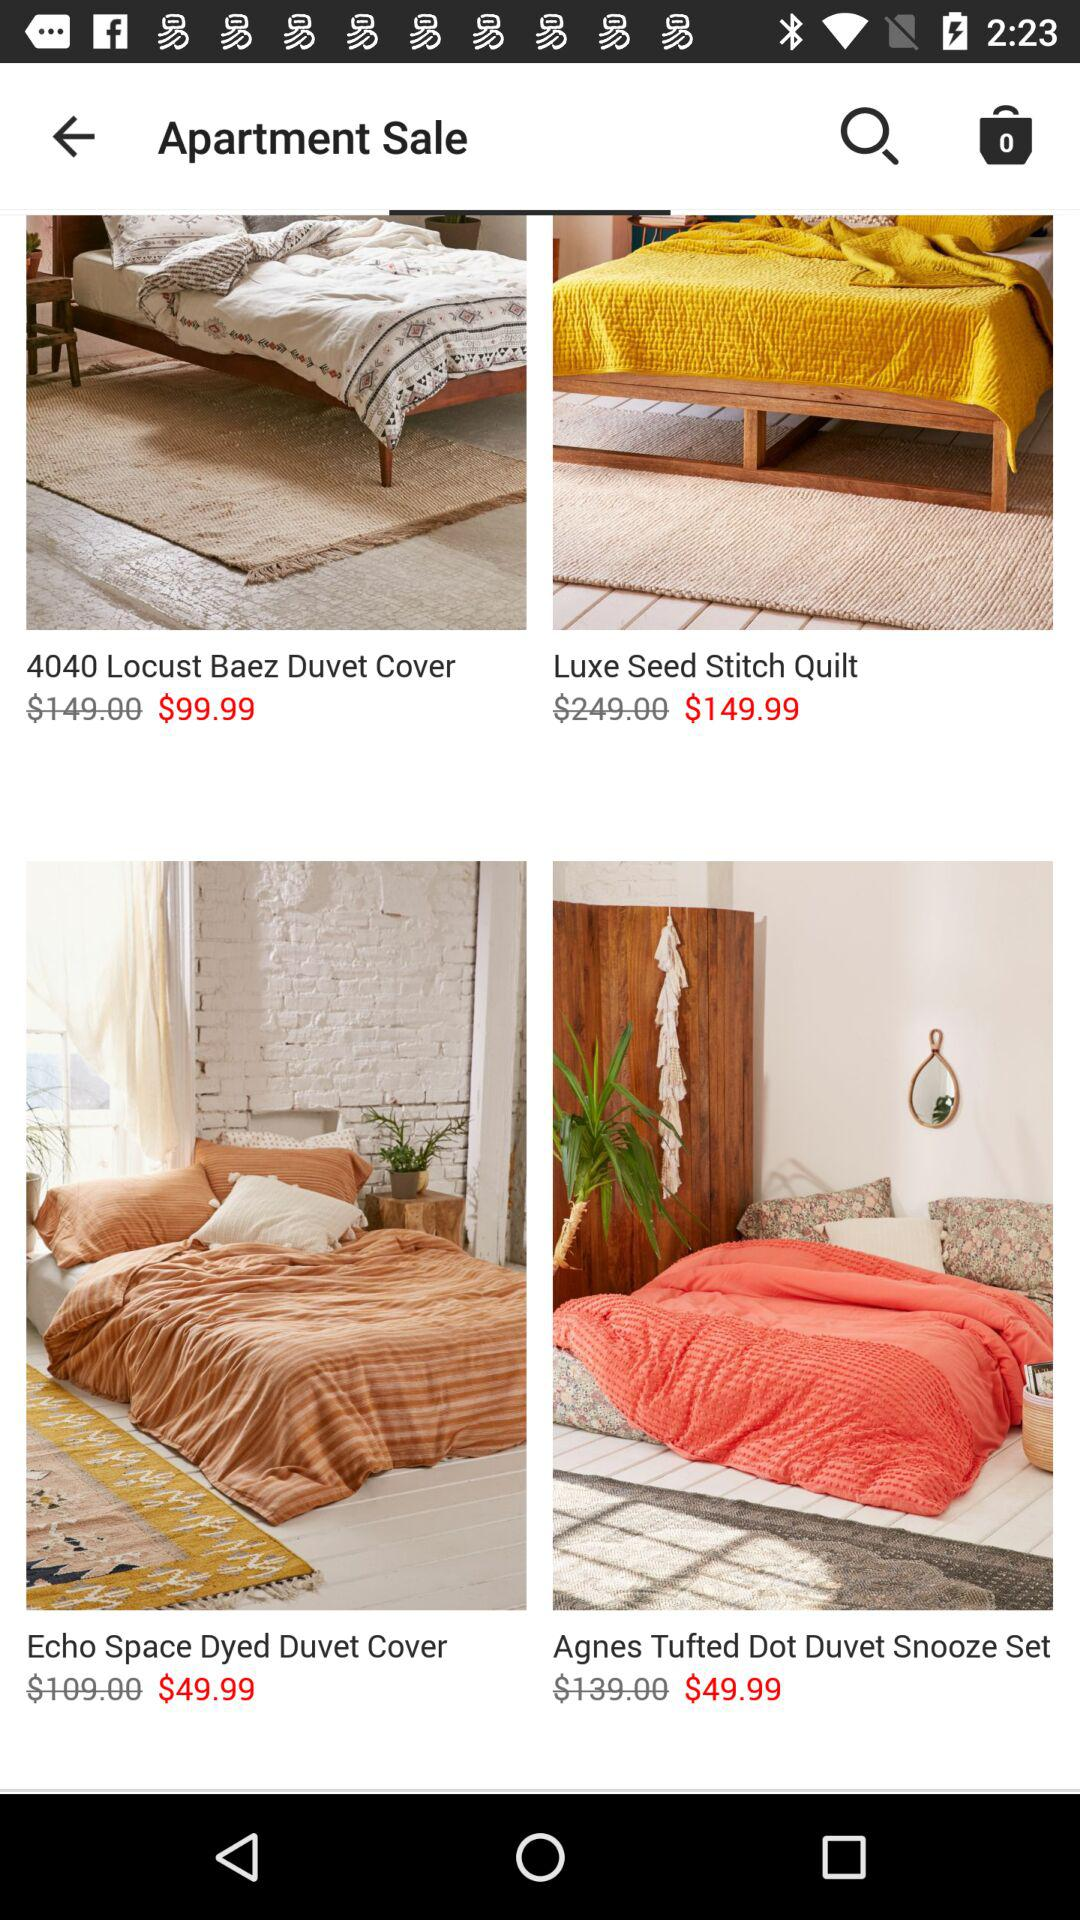How many items are priced below $100?
Answer the question using a single word or phrase. 3 